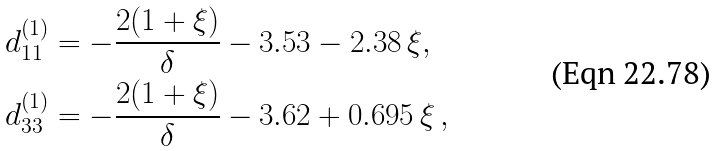Convert formula to latex. <formula><loc_0><loc_0><loc_500><loc_500>d _ { 1 1 } ^ { ( 1 ) } & = - \frac { 2 ( 1 + \xi ) } { \delta } - 3 . 5 3 - 2 . 3 8 \, \xi , \\ d _ { 3 3 } ^ { ( 1 ) } & = - \frac { 2 ( 1 + \xi ) } { \delta } - 3 . 6 2 + 0 . 6 9 5 \, \xi \, ,</formula> 